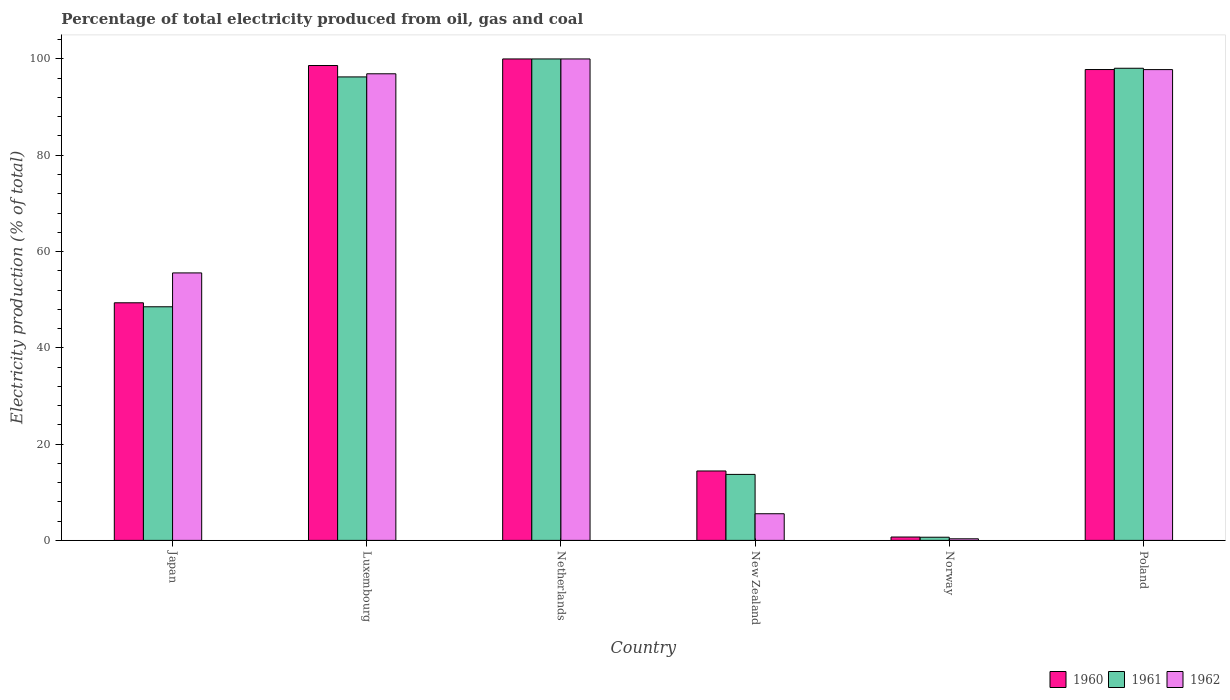How many different coloured bars are there?
Your answer should be compact. 3. What is the label of the 6th group of bars from the left?
Keep it short and to the point. Poland. What is the electricity production in in 1962 in Poland?
Offer a very short reply. 97.79. Across all countries, what is the minimum electricity production in in 1961?
Your answer should be compact. 0.66. In which country was the electricity production in in 1962 maximum?
Offer a terse response. Netherlands. In which country was the electricity production in in 1961 minimum?
Your answer should be very brief. Norway. What is the total electricity production in in 1960 in the graph?
Offer a very short reply. 360.9. What is the difference between the electricity production in in 1961 in Luxembourg and that in New Zealand?
Your answer should be very brief. 82.56. What is the difference between the electricity production in in 1961 in Poland and the electricity production in in 1962 in Netherlands?
Your answer should be compact. -1.93. What is the average electricity production in in 1962 per country?
Provide a short and direct response. 59.35. In how many countries, is the electricity production in in 1960 greater than 60 %?
Your response must be concise. 3. What is the ratio of the electricity production in in 1962 in Luxembourg to that in New Zealand?
Make the answer very short. 17.51. Is the electricity production in in 1962 in Luxembourg less than that in Norway?
Make the answer very short. No. What is the difference between the highest and the second highest electricity production in in 1962?
Your answer should be compact. -0.87. What is the difference between the highest and the lowest electricity production in in 1962?
Provide a short and direct response. 99.67. What does the 2nd bar from the left in Japan represents?
Keep it short and to the point. 1961. What does the 2nd bar from the right in Poland represents?
Your answer should be compact. 1961. Is it the case that in every country, the sum of the electricity production in in 1962 and electricity production in in 1960 is greater than the electricity production in in 1961?
Offer a very short reply. Yes. How many bars are there?
Make the answer very short. 18. Are all the bars in the graph horizontal?
Offer a terse response. No. What is the difference between two consecutive major ticks on the Y-axis?
Make the answer very short. 20. What is the title of the graph?
Give a very brief answer. Percentage of total electricity produced from oil, gas and coal. What is the label or title of the Y-axis?
Offer a terse response. Electricity production (% of total). What is the Electricity production (% of total) of 1960 in Japan?
Your answer should be compact. 49.35. What is the Electricity production (% of total) of 1961 in Japan?
Offer a terse response. 48.52. What is the Electricity production (% of total) of 1962 in Japan?
Ensure brevity in your answer.  55.56. What is the Electricity production (% of total) in 1960 in Luxembourg?
Give a very brief answer. 98.63. What is the Electricity production (% of total) in 1961 in Luxembourg?
Provide a short and direct response. 96.27. What is the Electricity production (% of total) in 1962 in Luxembourg?
Give a very brief answer. 96.92. What is the Electricity production (% of total) of 1960 in Netherlands?
Provide a short and direct response. 100. What is the Electricity production (% of total) in 1962 in Netherlands?
Provide a succinct answer. 100. What is the Electricity production (% of total) in 1960 in New Zealand?
Your response must be concise. 14.42. What is the Electricity production (% of total) in 1961 in New Zealand?
Provide a succinct answer. 13.71. What is the Electricity production (% of total) in 1962 in New Zealand?
Your answer should be compact. 5.54. What is the Electricity production (% of total) of 1960 in Norway?
Your answer should be compact. 0.7. What is the Electricity production (% of total) in 1961 in Norway?
Your answer should be very brief. 0.66. What is the Electricity production (% of total) of 1962 in Norway?
Provide a short and direct response. 0.33. What is the Electricity production (% of total) in 1960 in Poland?
Offer a terse response. 97.8. What is the Electricity production (% of total) in 1961 in Poland?
Provide a succinct answer. 98.07. What is the Electricity production (% of total) in 1962 in Poland?
Your answer should be compact. 97.79. Across all countries, what is the maximum Electricity production (% of total) of 1961?
Ensure brevity in your answer.  100. Across all countries, what is the maximum Electricity production (% of total) of 1962?
Give a very brief answer. 100. Across all countries, what is the minimum Electricity production (% of total) of 1960?
Offer a terse response. 0.7. Across all countries, what is the minimum Electricity production (% of total) of 1961?
Keep it short and to the point. 0.66. Across all countries, what is the minimum Electricity production (% of total) in 1962?
Offer a very short reply. 0.33. What is the total Electricity production (% of total) in 1960 in the graph?
Provide a succinct answer. 360.9. What is the total Electricity production (% of total) of 1961 in the graph?
Your answer should be very brief. 357.23. What is the total Electricity production (% of total) in 1962 in the graph?
Give a very brief answer. 356.13. What is the difference between the Electricity production (% of total) of 1960 in Japan and that in Luxembourg?
Your response must be concise. -49.28. What is the difference between the Electricity production (% of total) of 1961 in Japan and that in Luxembourg?
Give a very brief answer. -47.75. What is the difference between the Electricity production (% of total) of 1962 in Japan and that in Luxembourg?
Provide a short and direct response. -41.36. What is the difference between the Electricity production (% of total) of 1960 in Japan and that in Netherlands?
Provide a short and direct response. -50.65. What is the difference between the Electricity production (% of total) in 1961 in Japan and that in Netherlands?
Make the answer very short. -51.48. What is the difference between the Electricity production (% of total) of 1962 in Japan and that in Netherlands?
Provide a succinct answer. -44.44. What is the difference between the Electricity production (% of total) in 1960 in Japan and that in New Zealand?
Your answer should be very brief. 34.93. What is the difference between the Electricity production (% of total) in 1961 in Japan and that in New Zealand?
Ensure brevity in your answer.  34.82. What is the difference between the Electricity production (% of total) of 1962 in Japan and that in New Zealand?
Ensure brevity in your answer.  50.02. What is the difference between the Electricity production (% of total) of 1960 in Japan and that in Norway?
Provide a short and direct response. 48.65. What is the difference between the Electricity production (% of total) in 1961 in Japan and that in Norway?
Ensure brevity in your answer.  47.87. What is the difference between the Electricity production (% of total) of 1962 in Japan and that in Norway?
Give a very brief answer. 55.23. What is the difference between the Electricity production (% of total) in 1960 in Japan and that in Poland?
Provide a short and direct response. -48.45. What is the difference between the Electricity production (% of total) in 1961 in Japan and that in Poland?
Make the answer very short. -49.54. What is the difference between the Electricity production (% of total) in 1962 in Japan and that in Poland?
Ensure brevity in your answer.  -42.23. What is the difference between the Electricity production (% of total) of 1960 in Luxembourg and that in Netherlands?
Your answer should be compact. -1.37. What is the difference between the Electricity production (% of total) in 1961 in Luxembourg and that in Netherlands?
Provide a succinct answer. -3.73. What is the difference between the Electricity production (% of total) of 1962 in Luxembourg and that in Netherlands?
Offer a very short reply. -3.08. What is the difference between the Electricity production (% of total) in 1960 in Luxembourg and that in New Zealand?
Provide a succinct answer. 84.22. What is the difference between the Electricity production (% of total) in 1961 in Luxembourg and that in New Zealand?
Your answer should be compact. 82.56. What is the difference between the Electricity production (% of total) of 1962 in Luxembourg and that in New Zealand?
Offer a terse response. 91.38. What is the difference between the Electricity production (% of total) of 1960 in Luxembourg and that in Norway?
Your answer should be compact. 97.93. What is the difference between the Electricity production (% of total) in 1961 in Luxembourg and that in Norway?
Keep it short and to the point. 95.61. What is the difference between the Electricity production (% of total) in 1962 in Luxembourg and that in Norway?
Offer a very short reply. 96.59. What is the difference between the Electricity production (% of total) of 1960 in Luxembourg and that in Poland?
Offer a very short reply. 0.83. What is the difference between the Electricity production (% of total) in 1961 in Luxembourg and that in Poland?
Provide a succinct answer. -1.8. What is the difference between the Electricity production (% of total) in 1962 in Luxembourg and that in Poland?
Provide a succinct answer. -0.87. What is the difference between the Electricity production (% of total) of 1960 in Netherlands and that in New Zealand?
Give a very brief answer. 85.58. What is the difference between the Electricity production (% of total) of 1961 in Netherlands and that in New Zealand?
Keep it short and to the point. 86.29. What is the difference between the Electricity production (% of total) in 1962 in Netherlands and that in New Zealand?
Offer a terse response. 94.46. What is the difference between the Electricity production (% of total) of 1960 in Netherlands and that in Norway?
Keep it short and to the point. 99.3. What is the difference between the Electricity production (% of total) of 1961 in Netherlands and that in Norway?
Provide a succinct answer. 99.34. What is the difference between the Electricity production (% of total) in 1962 in Netherlands and that in Norway?
Keep it short and to the point. 99.67. What is the difference between the Electricity production (% of total) of 1960 in Netherlands and that in Poland?
Give a very brief answer. 2.2. What is the difference between the Electricity production (% of total) of 1961 in Netherlands and that in Poland?
Offer a very short reply. 1.93. What is the difference between the Electricity production (% of total) of 1962 in Netherlands and that in Poland?
Your response must be concise. 2.21. What is the difference between the Electricity production (% of total) of 1960 in New Zealand and that in Norway?
Your response must be concise. 13.72. What is the difference between the Electricity production (% of total) of 1961 in New Zealand and that in Norway?
Provide a succinct answer. 13.05. What is the difference between the Electricity production (% of total) in 1962 in New Zealand and that in Norway?
Offer a terse response. 5.21. What is the difference between the Electricity production (% of total) of 1960 in New Zealand and that in Poland?
Provide a succinct answer. -83.38. What is the difference between the Electricity production (% of total) in 1961 in New Zealand and that in Poland?
Offer a very short reply. -84.36. What is the difference between the Electricity production (% of total) of 1962 in New Zealand and that in Poland?
Your answer should be compact. -92.25. What is the difference between the Electricity production (% of total) of 1960 in Norway and that in Poland?
Your answer should be very brief. -97.1. What is the difference between the Electricity production (% of total) of 1961 in Norway and that in Poland?
Keep it short and to the point. -97.41. What is the difference between the Electricity production (% of total) in 1962 in Norway and that in Poland?
Your answer should be compact. -97.46. What is the difference between the Electricity production (% of total) in 1960 in Japan and the Electricity production (% of total) in 1961 in Luxembourg?
Offer a terse response. -46.92. What is the difference between the Electricity production (% of total) in 1960 in Japan and the Electricity production (% of total) in 1962 in Luxembourg?
Your answer should be compact. -47.57. What is the difference between the Electricity production (% of total) in 1961 in Japan and the Electricity production (% of total) in 1962 in Luxembourg?
Ensure brevity in your answer.  -48.39. What is the difference between the Electricity production (% of total) of 1960 in Japan and the Electricity production (% of total) of 1961 in Netherlands?
Your response must be concise. -50.65. What is the difference between the Electricity production (% of total) of 1960 in Japan and the Electricity production (% of total) of 1962 in Netherlands?
Give a very brief answer. -50.65. What is the difference between the Electricity production (% of total) of 1961 in Japan and the Electricity production (% of total) of 1962 in Netherlands?
Keep it short and to the point. -51.48. What is the difference between the Electricity production (% of total) of 1960 in Japan and the Electricity production (% of total) of 1961 in New Zealand?
Keep it short and to the point. 35.64. What is the difference between the Electricity production (% of total) of 1960 in Japan and the Electricity production (% of total) of 1962 in New Zealand?
Give a very brief answer. 43.81. What is the difference between the Electricity production (% of total) in 1961 in Japan and the Electricity production (% of total) in 1962 in New Zealand?
Your answer should be compact. 42.99. What is the difference between the Electricity production (% of total) in 1960 in Japan and the Electricity production (% of total) in 1961 in Norway?
Ensure brevity in your answer.  48.69. What is the difference between the Electricity production (% of total) of 1960 in Japan and the Electricity production (% of total) of 1962 in Norway?
Your response must be concise. 49.02. What is the difference between the Electricity production (% of total) of 1961 in Japan and the Electricity production (% of total) of 1962 in Norway?
Offer a very short reply. 48.19. What is the difference between the Electricity production (% of total) of 1960 in Japan and the Electricity production (% of total) of 1961 in Poland?
Provide a succinct answer. -48.72. What is the difference between the Electricity production (% of total) in 1960 in Japan and the Electricity production (% of total) in 1962 in Poland?
Offer a very short reply. -48.44. What is the difference between the Electricity production (% of total) of 1961 in Japan and the Electricity production (% of total) of 1962 in Poland?
Your answer should be very brief. -49.26. What is the difference between the Electricity production (% of total) in 1960 in Luxembourg and the Electricity production (% of total) in 1961 in Netherlands?
Give a very brief answer. -1.37. What is the difference between the Electricity production (% of total) in 1960 in Luxembourg and the Electricity production (% of total) in 1962 in Netherlands?
Your answer should be compact. -1.37. What is the difference between the Electricity production (% of total) in 1961 in Luxembourg and the Electricity production (% of total) in 1962 in Netherlands?
Your response must be concise. -3.73. What is the difference between the Electricity production (% of total) of 1960 in Luxembourg and the Electricity production (% of total) of 1961 in New Zealand?
Offer a very short reply. 84.93. What is the difference between the Electricity production (% of total) of 1960 in Luxembourg and the Electricity production (% of total) of 1962 in New Zealand?
Offer a terse response. 93.1. What is the difference between the Electricity production (% of total) of 1961 in Luxembourg and the Electricity production (% of total) of 1962 in New Zealand?
Your answer should be very brief. 90.73. What is the difference between the Electricity production (% of total) in 1960 in Luxembourg and the Electricity production (% of total) in 1961 in Norway?
Make the answer very short. 97.98. What is the difference between the Electricity production (% of total) of 1960 in Luxembourg and the Electricity production (% of total) of 1962 in Norway?
Your response must be concise. 98.3. What is the difference between the Electricity production (% of total) of 1961 in Luxembourg and the Electricity production (% of total) of 1962 in Norway?
Ensure brevity in your answer.  95.94. What is the difference between the Electricity production (% of total) in 1960 in Luxembourg and the Electricity production (% of total) in 1961 in Poland?
Provide a succinct answer. 0.57. What is the difference between the Electricity production (% of total) in 1960 in Luxembourg and the Electricity production (% of total) in 1962 in Poland?
Provide a succinct answer. 0.85. What is the difference between the Electricity production (% of total) of 1961 in Luxembourg and the Electricity production (% of total) of 1962 in Poland?
Offer a terse response. -1.52. What is the difference between the Electricity production (% of total) in 1960 in Netherlands and the Electricity production (% of total) in 1961 in New Zealand?
Offer a terse response. 86.29. What is the difference between the Electricity production (% of total) in 1960 in Netherlands and the Electricity production (% of total) in 1962 in New Zealand?
Offer a terse response. 94.46. What is the difference between the Electricity production (% of total) of 1961 in Netherlands and the Electricity production (% of total) of 1962 in New Zealand?
Offer a terse response. 94.46. What is the difference between the Electricity production (% of total) in 1960 in Netherlands and the Electricity production (% of total) in 1961 in Norway?
Make the answer very short. 99.34. What is the difference between the Electricity production (% of total) in 1960 in Netherlands and the Electricity production (% of total) in 1962 in Norway?
Give a very brief answer. 99.67. What is the difference between the Electricity production (% of total) of 1961 in Netherlands and the Electricity production (% of total) of 1962 in Norway?
Offer a very short reply. 99.67. What is the difference between the Electricity production (% of total) in 1960 in Netherlands and the Electricity production (% of total) in 1961 in Poland?
Your answer should be compact. 1.93. What is the difference between the Electricity production (% of total) of 1960 in Netherlands and the Electricity production (% of total) of 1962 in Poland?
Provide a succinct answer. 2.21. What is the difference between the Electricity production (% of total) in 1961 in Netherlands and the Electricity production (% of total) in 1962 in Poland?
Your answer should be very brief. 2.21. What is the difference between the Electricity production (% of total) in 1960 in New Zealand and the Electricity production (% of total) in 1961 in Norway?
Give a very brief answer. 13.76. What is the difference between the Electricity production (% of total) in 1960 in New Zealand and the Electricity production (% of total) in 1962 in Norway?
Provide a succinct answer. 14.09. What is the difference between the Electricity production (% of total) of 1961 in New Zealand and the Electricity production (% of total) of 1962 in Norway?
Provide a succinct answer. 13.38. What is the difference between the Electricity production (% of total) in 1960 in New Zealand and the Electricity production (% of total) in 1961 in Poland?
Provide a short and direct response. -83.65. What is the difference between the Electricity production (% of total) in 1960 in New Zealand and the Electricity production (% of total) in 1962 in Poland?
Your answer should be compact. -83.37. What is the difference between the Electricity production (% of total) in 1961 in New Zealand and the Electricity production (% of total) in 1962 in Poland?
Provide a short and direct response. -84.08. What is the difference between the Electricity production (% of total) of 1960 in Norway and the Electricity production (% of total) of 1961 in Poland?
Your answer should be very brief. -97.37. What is the difference between the Electricity production (% of total) of 1960 in Norway and the Electricity production (% of total) of 1962 in Poland?
Make the answer very short. -97.09. What is the difference between the Electricity production (% of total) in 1961 in Norway and the Electricity production (% of total) in 1962 in Poland?
Give a very brief answer. -97.13. What is the average Electricity production (% of total) in 1960 per country?
Your answer should be compact. 60.15. What is the average Electricity production (% of total) of 1961 per country?
Your response must be concise. 59.54. What is the average Electricity production (% of total) in 1962 per country?
Your answer should be compact. 59.35. What is the difference between the Electricity production (% of total) of 1960 and Electricity production (% of total) of 1961 in Japan?
Your answer should be compact. 0.83. What is the difference between the Electricity production (% of total) in 1960 and Electricity production (% of total) in 1962 in Japan?
Offer a terse response. -6.2. What is the difference between the Electricity production (% of total) in 1961 and Electricity production (% of total) in 1962 in Japan?
Your answer should be compact. -7.03. What is the difference between the Electricity production (% of total) in 1960 and Electricity production (% of total) in 1961 in Luxembourg?
Provide a short and direct response. 2.36. What is the difference between the Electricity production (% of total) of 1960 and Electricity production (% of total) of 1962 in Luxembourg?
Ensure brevity in your answer.  1.72. What is the difference between the Electricity production (% of total) of 1961 and Electricity production (% of total) of 1962 in Luxembourg?
Your response must be concise. -0.65. What is the difference between the Electricity production (% of total) in 1961 and Electricity production (% of total) in 1962 in Netherlands?
Offer a very short reply. 0. What is the difference between the Electricity production (% of total) of 1960 and Electricity production (% of total) of 1961 in New Zealand?
Provide a succinct answer. 0.71. What is the difference between the Electricity production (% of total) of 1960 and Electricity production (% of total) of 1962 in New Zealand?
Offer a terse response. 8.88. What is the difference between the Electricity production (% of total) of 1961 and Electricity production (% of total) of 1962 in New Zealand?
Your answer should be very brief. 8.17. What is the difference between the Electricity production (% of total) in 1960 and Electricity production (% of total) in 1961 in Norway?
Offer a very short reply. 0.04. What is the difference between the Electricity production (% of total) of 1960 and Electricity production (% of total) of 1962 in Norway?
Your response must be concise. 0.37. What is the difference between the Electricity production (% of total) of 1961 and Electricity production (% of total) of 1962 in Norway?
Offer a terse response. 0.33. What is the difference between the Electricity production (% of total) of 1960 and Electricity production (% of total) of 1961 in Poland?
Keep it short and to the point. -0.27. What is the difference between the Electricity production (% of total) in 1960 and Electricity production (% of total) in 1962 in Poland?
Make the answer very short. 0.01. What is the difference between the Electricity production (% of total) of 1961 and Electricity production (% of total) of 1962 in Poland?
Offer a terse response. 0.28. What is the ratio of the Electricity production (% of total) in 1960 in Japan to that in Luxembourg?
Provide a succinct answer. 0.5. What is the ratio of the Electricity production (% of total) in 1961 in Japan to that in Luxembourg?
Ensure brevity in your answer.  0.5. What is the ratio of the Electricity production (% of total) in 1962 in Japan to that in Luxembourg?
Make the answer very short. 0.57. What is the ratio of the Electricity production (% of total) of 1960 in Japan to that in Netherlands?
Ensure brevity in your answer.  0.49. What is the ratio of the Electricity production (% of total) of 1961 in Japan to that in Netherlands?
Offer a very short reply. 0.49. What is the ratio of the Electricity production (% of total) in 1962 in Japan to that in Netherlands?
Offer a very short reply. 0.56. What is the ratio of the Electricity production (% of total) in 1960 in Japan to that in New Zealand?
Provide a short and direct response. 3.42. What is the ratio of the Electricity production (% of total) of 1961 in Japan to that in New Zealand?
Your response must be concise. 3.54. What is the ratio of the Electricity production (% of total) of 1962 in Japan to that in New Zealand?
Provide a short and direct response. 10.03. What is the ratio of the Electricity production (% of total) of 1960 in Japan to that in Norway?
Your response must be concise. 70.54. What is the ratio of the Electricity production (% of total) in 1961 in Japan to that in Norway?
Give a very brief answer. 73.86. What is the ratio of the Electricity production (% of total) of 1962 in Japan to that in Norway?
Your response must be concise. 168.11. What is the ratio of the Electricity production (% of total) of 1960 in Japan to that in Poland?
Your answer should be very brief. 0.5. What is the ratio of the Electricity production (% of total) in 1961 in Japan to that in Poland?
Offer a very short reply. 0.49. What is the ratio of the Electricity production (% of total) of 1962 in Japan to that in Poland?
Give a very brief answer. 0.57. What is the ratio of the Electricity production (% of total) in 1960 in Luxembourg to that in Netherlands?
Provide a succinct answer. 0.99. What is the ratio of the Electricity production (% of total) of 1961 in Luxembourg to that in Netherlands?
Provide a short and direct response. 0.96. What is the ratio of the Electricity production (% of total) of 1962 in Luxembourg to that in Netherlands?
Your answer should be compact. 0.97. What is the ratio of the Electricity production (% of total) of 1960 in Luxembourg to that in New Zealand?
Your answer should be compact. 6.84. What is the ratio of the Electricity production (% of total) of 1961 in Luxembourg to that in New Zealand?
Offer a terse response. 7.02. What is the ratio of the Electricity production (% of total) of 1962 in Luxembourg to that in New Zealand?
Offer a terse response. 17.51. What is the ratio of the Electricity production (% of total) in 1960 in Luxembourg to that in Norway?
Offer a very short reply. 140.97. What is the ratio of the Electricity production (% of total) in 1961 in Luxembourg to that in Norway?
Your answer should be compact. 146.53. What is the ratio of the Electricity production (% of total) of 1962 in Luxembourg to that in Norway?
Make the answer very short. 293.27. What is the ratio of the Electricity production (% of total) of 1960 in Luxembourg to that in Poland?
Offer a terse response. 1.01. What is the ratio of the Electricity production (% of total) in 1961 in Luxembourg to that in Poland?
Ensure brevity in your answer.  0.98. What is the ratio of the Electricity production (% of total) of 1960 in Netherlands to that in New Zealand?
Make the answer very short. 6.94. What is the ratio of the Electricity production (% of total) in 1961 in Netherlands to that in New Zealand?
Make the answer very short. 7.29. What is the ratio of the Electricity production (% of total) in 1962 in Netherlands to that in New Zealand?
Your answer should be compact. 18.06. What is the ratio of the Electricity production (% of total) of 1960 in Netherlands to that in Norway?
Your answer should be very brief. 142.93. What is the ratio of the Electricity production (% of total) of 1961 in Netherlands to that in Norway?
Ensure brevity in your answer.  152.21. What is the ratio of the Electricity production (% of total) of 1962 in Netherlands to that in Norway?
Offer a very short reply. 302.6. What is the ratio of the Electricity production (% of total) in 1960 in Netherlands to that in Poland?
Your answer should be very brief. 1.02. What is the ratio of the Electricity production (% of total) of 1961 in Netherlands to that in Poland?
Your answer should be very brief. 1.02. What is the ratio of the Electricity production (% of total) of 1962 in Netherlands to that in Poland?
Provide a short and direct response. 1.02. What is the ratio of the Electricity production (% of total) of 1960 in New Zealand to that in Norway?
Your response must be concise. 20.61. What is the ratio of the Electricity production (% of total) of 1961 in New Zealand to that in Norway?
Ensure brevity in your answer.  20.87. What is the ratio of the Electricity production (% of total) of 1962 in New Zealand to that in Norway?
Your response must be concise. 16.75. What is the ratio of the Electricity production (% of total) of 1960 in New Zealand to that in Poland?
Make the answer very short. 0.15. What is the ratio of the Electricity production (% of total) in 1961 in New Zealand to that in Poland?
Provide a short and direct response. 0.14. What is the ratio of the Electricity production (% of total) in 1962 in New Zealand to that in Poland?
Ensure brevity in your answer.  0.06. What is the ratio of the Electricity production (% of total) of 1960 in Norway to that in Poland?
Ensure brevity in your answer.  0.01. What is the ratio of the Electricity production (% of total) of 1961 in Norway to that in Poland?
Offer a terse response. 0.01. What is the ratio of the Electricity production (% of total) in 1962 in Norway to that in Poland?
Ensure brevity in your answer.  0. What is the difference between the highest and the second highest Electricity production (% of total) of 1960?
Your answer should be compact. 1.37. What is the difference between the highest and the second highest Electricity production (% of total) in 1961?
Your answer should be very brief. 1.93. What is the difference between the highest and the second highest Electricity production (% of total) in 1962?
Offer a terse response. 2.21. What is the difference between the highest and the lowest Electricity production (% of total) in 1960?
Your answer should be compact. 99.3. What is the difference between the highest and the lowest Electricity production (% of total) in 1961?
Ensure brevity in your answer.  99.34. What is the difference between the highest and the lowest Electricity production (% of total) of 1962?
Give a very brief answer. 99.67. 